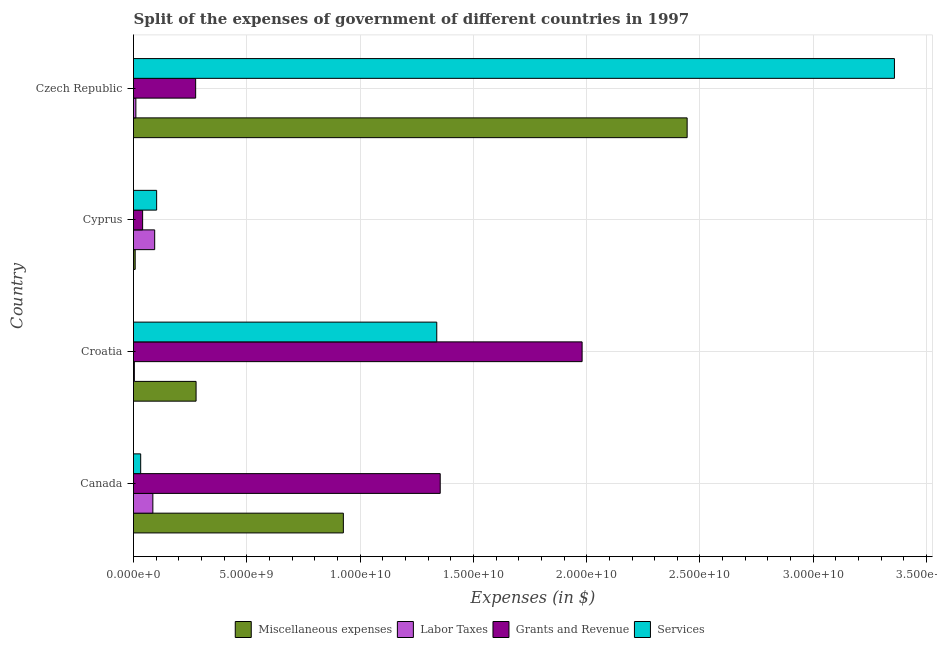How many groups of bars are there?
Make the answer very short. 4. Are the number of bars per tick equal to the number of legend labels?
Provide a succinct answer. Yes. Are the number of bars on each tick of the Y-axis equal?
Keep it short and to the point. Yes. How many bars are there on the 1st tick from the top?
Ensure brevity in your answer.  4. What is the label of the 3rd group of bars from the top?
Provide a short and direct response. Croatia. In how many cases, is the number of bars for a given country not equal to the number of legend labels?
Offer a very short reply. 0. What is the amount spent on services in Canada?
Keep it short and to the point. 3.17e+08. Across all countries, what is the maximum amount spent on grants and revenue?
Your answer should be very brief. 1.98e+1. Across all countries, what is the minimum amount spent on services?
Offer a very short reply. 3.17e+08. In which country was the amount spent on services maximum?
Ensure brevity in your answer.  Czech Republic. In which country was the amount spent on grants and revenue minimum?
Make the answer very short. Cyprus. What is the total amount spent on grants and revenue in the graph?
Keep it short and to the point. 3.65e+1. What is the difference between the amount spent on grants and revenue in Croatia and that in Cyprus?
Give a very brief answer. 1.94e+1. What is the difference between the amount spent on miscellaneous expenses in Croatia and the amount spent on services in Cyprus?
Ensure brevity in your answer.  1.74e+09. What is the average amount spent on labor taxes per country?
Provide a short and direct response. 4.83e+08. What is the difference between the amount spent on grants and revenue and amount spent on miscellaneous expenses in Canada?
Your response must be concise. 4.28e+09. What is the ratio of the amount spent on grants and revenue in Canada to that in Czech Republic?
Give a very brief answer. 4.93. What is the difference between the highest and the second highest amount spent on grants and revenue?
Your answer should be very brief. 6.26e+09. What is the difference between the highest and the lowest amount spent on miscellaneous expenses?
Provide a succinct answer. 2.44e+1. Is the sum of the amount spent on miscellaneous expenses in Canada and Czech Republic greater than the maximum amount spent on services across all countries?
Keep it short and to the point. Yes. Is it the case that in every country, the sum of the amount spent on grants and revenue and amount spent on services is greater than the sum of amount spent on labor taxes and amount spent on miscellaneous expenses?
Provide a succinct answer. No. What does the 4th bar from the top in Cyprus represents?
Make the answer very short. Miscellaneous expenses. What does the 4th bar from the bottom in Canada represents?
Give a very brief answer. Services. Is it the case that in every country, the sum of the amount spent on miscellaneous expenses and amount spent on labor taxes is greater than the amount spent on grants and revenue?
Your answer should be very brief. No. How many bars are there?
Ensure brevity in your answer.  16. How many countries are there in the graph?
Offer a terse response. 4. Are the values on the major ticks of X-axis written in scientific E-notation?
Your response must be concise. Yes. Does the graph contain grids?
Offer a very short reply. Yes. Where does the legend appear in the graph?
Make the answer very short. Bottom center. How are the legend labels stacked?
Your response must be concise. Horizontal. What is the title of the graph?
Give a very brief answer. Split of the expenses of government of different countries in 1997. What is the label or title of the X-axis?
Your answer should be compact. Expenses (in $). What is the Expenses (in $) of Miscellaneous expenses in Canada?
Ensure brevity in your answer.  9.26e+09. What is the Expenses (in $) of Labor Taxes in Canada?
Offer a very short reply. 8.54e+08. What is the Expenses (in $) in Grants and Revenue in Canada?
Ensure brevity in your answer.  1.35e+1. What is the Expenses (in $) in Services in Canada?
Keep it short and to the point. 3.17e+08. What is the Expenses (in $) of Miscellaneous expenses in Croatia?
Keep it short and to the point. 2.76e+09. What is the Expenses (in $) of Labor Taxes in Croatia?
Make the answer very short. 3.79e+07. What is the Expenses (in $) of Grants and Revenue in Croatia?
Offer a terse response. 1.98e+1. What is the Expenses (in $) of Services in Croatia?
Ensure brevity in your answer.  1.34e+1. What is the Expenses (in $) of Miscellaneous expenses in Cyprus?
Keep it short and to the point. 7.36e+07. What is the Expenses (in $) of Labor Taxes in Cyprus?
Keep it short and to the point. 9.35e+08. What is the Expenses (in $) of Grants and Revenue in Cyprus?
Give a very brief answer. 4.02e+08. What is the Expenses (in $) in Services in Cyprus?
Give a very brief answer. 1.02e+09. What is the Expenses (in $) of Miscellaneous expenses in Czech Republic?
Give a very brief answer. 2.44e+1. What is the Expenses (in $) in Labor Taxes in Czech Republic?
Your answer should be very brief. 1.05e+08. What is the Expenses (in $) in Grants and Revenue in Czech Republic?
Provide a short and direct response. 2.74e+09. What is the Expenses (in $) of Services in Czech Republic?
Your response must be concise. 3.36e+1. Across all countries, what is the maximum Expenses (in $) in Miscellaneous expenses?
Make the answer very short. 2.44e+1. Across all countries, what is the maximum Expenses (in $) of Labor Taxes?
Your response must be concise. 9.35e+08. Across all countries, what is the maximum Expenses (in $) of Grants and Revenue?
Your answer should be very brief. 1.98e+1. Across all countries, what is the maximum Expenses (in $) in Services?
Ensure brevity in your answer.  3.36e+1. Across all countries, what is the minimum Expenses (in $) of Miscellaneous expenses?
Your answer should be very brief. 7.36e+07. Across all countries, what is the minimum Expenses (in $) in Labor Taxes?
Your response must be concise. 3.79e+07. Across all countries, what is the minimum Expenses (in $) of Grants and Revenue?
Keep it short and to the point. 4.02e+08. Across all countries, what is the minimum Expenses (in $) of Services?
Provide a succinct answer. 3.17e+08. What is the total Expenses (in $) of Miscellaneous expenses in the graph?
Ensure brevity in your answer.  3.65e+1. What is the total Expenses (in $) of Labor Taxes in the graph?
Provide a succinct answer. 1.93e+09. What is the total Expenses (in $) in Grants and Revenue in the graph?
Provide a succinct answer. 3.65e+1. What is the total Expenses (in $) in Services in the graph?
Give a very brief answer. 4.83e+1. What is the difference between the Expenses (in $) of Miscellaneous expenses in Canada and that in Croatia?
Offer a very short reply. 6.50e+09. What is the difference between the Expenses (in $) in Labor Taxes in Canada and that in Croatia?
Provide a succinct answer. 8.16e+08. What is the difference between the Expenses (in $) in Grants and Revenue in Canada and that in Croatia?
Keep it short and to the point. -6.26e+09. What is the difference between the Expenses (in $) of Services in Canada and that in Croatia?
Keep it short and to the point. -1.31e+1. What is the difference between the Expenses (in $) of Miscellaneous expenses in Canada and that in Cyprus?
Give a very brief answer. 9.19e+09. What is the difference between the Expenses (in $) in Labor Taxes in Canada and that in Cyprus?
Offer a terse response. -8.05e+07. What is the difference between the Expenses (in $) of Grants and Revenue in Canada and that in Cyprus?
Ensure brevity in your answer.  1.31e+1. What is the difference between the Expenses (in $) of Services in Canada and that in Cyprus?
Your response must be concise. -7.04e+08. What is the difference between the Expenses (in $) of Miscellaneous expenses in Canada and that in Czech Republic?
Provide a succinct answer. -1.52e+1. What is the difference between the Expenses (in $) in Labor Taxes in Canada and that in Czech Republic?
Offer a very short reply. 7.49e+08. What is the difference between the Expenses (in $) in Grants and Revenue in Canada and that in Czech Republic?
Offer a very short reply. 1.08e+1. What is the difference between the Expenses (in $) of Services in Canada and that in Czech Republic?
Offer a terse response. -3.33e+1. What is the difference between the Expenses (in $) in Miscellaneous expenses in Croatia and that in Cyprus?
Your answer should be compact. 2.69e+09. What is the difference between the Expenses (in $) in Labor Taxes in Croatia and that in Cyprus?
Keep it short and to the point. -8.97e+08. What is the difference between the Expenses (in $) in Grants and Revenue in Croatia and that in Cyprus?
Make the answer very short. 1.94e+1. What is the difference between the Expenses (in $) of Services in Croatia and that in Cyprus?
Your response must be concise. 1.24e+1. What is the difference between the Expenses (in $) in Miscellaneous expenses in Croatia and that in Czech Republic?
Keep it short and to the point. -2.17e+1. What is the difference between the Expenses (in $) of Labor Taxes in Croatia and that in Czech Republic?
Keep it short and to the point. -6.69e+07. What is the difference between the Expenses (in $) in Grants and Revenue in Croatia and that in Czech Republic?
Ensure brevity in your answer.  1.71e+1. What is the difference between the Expenses (in $) of Services in Croatia and that in Czech Republic?
Provide a succinct answer. -2.02e+1. What is the difference between the Expenses (in $) of Miscellaneous expenses in Cyprus and that in Czech Republic?
Your response must be concise. -2.44e+1. What is the difference between the Expenses (in $) of Labor Taxes in Cyprus and that in Czech Republic?
Offer a very short reply. 8.30e+08. What is the difference between the Expenses (in $) in Grants and Revenue in Cyprus and that in Czech Republic?
Make the answer very short. -2.34e+09. What is the difference between the Expenses (in $) of Services in Cyprus and that in Czech Republic?
Offer a terse response. -3.26e+1. What is the difference between the Expenses (in $) in Miscellaneous expenses in Canada and the Expenses (in $) in Labor Taxes in Croatia?
Your response must be concise. 9.22e+09. What is the difference between the Expenses (in $) of Miscellaneous expenses in Canada and the Expenses (in $) of Grants and Revenue in Croatia?
Keep it short and to the point. -1.05e+1. What is the difference between the Expenses (in $) in Miscellaneous expenses in Canada and the Expenses (in $) in Services in Croatia?
Offer a terse response. -4.12e+09. What is the difference between the Expenses (in $) of Labor Taxes in Canada and the Expenses (in $) of Grants and Revenue in Croatia?
Ensure brevity in your answer.  -1.89e+1. What is the difference between the Expenses (in $) in Labor Taxes in Canada and the Expenses (in $) in Services in Croatia?
Your answer should be very brief. -1.25e+1. What is the difference between the Expenses (in $) of Grants and Revenue in Canada and the Expenses (in $) of Services in Croatia?
Offer a terse response. 1.52e+08. What is the difference between the Expenses (in $) in Miscellaneous expenses in Canada and the Expenses (in $) in Labor Taxes in Cyprus?
Keep it short and to the point. 8.33e+09. What is the difference between the Expenses (in $) of Miscellaneous expenses in Canada and the Expenses (in $) of Grants and Revenue in Cyprus?
Offer a terse response. 8.86e+09. What is the difference between the Expenses (in $) in Miscellaneous expenses in Canada and the Expenses (in $) in Services in Cyprus?
Your response must be concise. 8.24e+09. What is the difference between the Expenses (in $) in Labor Taxes in Canada and the Expenses (in $) in Grants and Revenue in Cyprus?
Your answer should be compact. 4.52e+08. What is the difference between the Expenses (in $) in Labor Taxes in Canada and the Expenses (in $) in Services in Cyprus?
Ensure brevity in your answer.  -1.67e+08. What is the difference between the Expenses (in $) of Grants and Revenue in Canada and the Expenses (in $) of Services in Cyprus?
Your answer should be compact. 1.25e+1. What is the difference between the Expenses (in $) of Miscellaneous expenses in Canada and the Expenses (in $) of Labor Taxes in Czech Republic?
Give a very brief answer. 9.16e+09. What is the difference between the Expenses (in $) in Miscellaneous expenses in Canada and the Expenses (in $) in Grants and Revenue in Czech Republic?
Keep it short and to the point. 6.52e+09. What is the difference between the Expenses (in $) of Miscellaneous expenses in Canada and the Expenses (in $) of Services in Czech Republic?
Keep it short and to the point. -2.43e+1. What is the difference between the Expenses (in $) of Labor Taxes in Canada and the Expenses (in $) of Grants and Revenue in Czech Republic?
Provide a short and direct response. -1.89e+09. What is the difference between the Expenses (in $) of Labor Taxes in Canada and the Expenses (in $) of Services in Czech Republic?
Make the answer very short. -3.27e+1. What is the difference between the Expenses (in $) of Grants and Revenue in Canada and the Expenses (in $) of Services in Czech Republic?
Keep it short and to the point. -2.00e+1. What is the difference between the Expenses (in $) in Miscellaneous expenses in Croatia and the Expenses (in $) in Labor Taxes in Cyprus?
Give a very brief answer. 1.83e+09. What is the difference between the Expenses (in $) in Miscellaneous expenses in Croatia and the Expenses (in $) in Grants and Revenue in Cyprus?
Give a very brief answer. 2.36e+09. What is the difference between the Expenses (in $) in Miscellaneous expenses in Croatia and the Expenses (in $) in Services in Cyprus?
Your response must be concise. 1.74e+09. What is the difference between the Expenses (in $) of Labor Taxes in Croatia and the Expenses (in $) of Grants and Revenue in Cyprus?
Make the answer very short. -3.64e+08. What is the difference between the Expenses (in $) in Labor Taxes in Croatia and the Expenses (in $) in Services in Cyprus?
Offer a terse response. -9.83e+08. What is the difference between the Expenses (in $) of Grants and Revenue in Croatia and the Expenses (in $) of Services in Cyprus?
Give a very brief answer. 1.88e+1. What is the difference between the Expenses (in $) of Miscellaneous expenses in Croatia and the Expenses (in $) of Labor Taxes in Czech Republic?
Keep it short and to the point. 2.66e+09. What is the difference between the Expenses (in $) of Miscellaneous expenses in Croatia and the Expenses (in $) of Grants and Revenue in Czech Republic?
Provide a short and direct response. 1.83e+07. What is the difference between the Expenses (in $) in Miscellaneous expenses in Croatia and the Expenses (in $) in Services in Czech Republic?
Your answer should be compact. -3.08e+1. What is the difference between the Expenses (in $) in Labor Taxes in Croatia and the Expenses (in $) in Grants and Revenue in Czech Republic?
Offer a terse response. -2.70e+09. What is the difference between the Expenses (in $) in Labor Taxes in Croatia and the Expenses (in $) in Services in Czech Republic?
Your answer should be very brief. -3.35e+1. What is the difference between the Expenses (in $) in Grants and Revenue in Croatia and the Expenses (in $) in Services in Czech Republic?
Provide a short and direct response. -1.38e+1. What is the difference between the Expenses (in $) in Miscellaneous expenses in Cyprus and the Expenses (in $) in Labor Taxes in Czech Republic?
Ensure brevity in your answer.  -3.12e+07. What is the difference between the Expenses (in $) of Miscellaneous expenses in Cyprus and the Expenses (in $) of Grants and Revenue in Czech Republic?
Offer a very short reply. -2.67e+09. What is the difference between the Expenses (in $) in Miscellaneous expenses in Cyprus and the Expenses (in $) in Services in Czech Republic?
Make the answer very short. -3.35e+1. What is the difference between the Expenses (in $) of Labor Taxes in Cyprus and the Expenses (in $) of Grants and Revenue in Czech Republic?
Provide a succinct answer. -1.81e+09. What is the difference between the Expenses (in $) of Labor Taxes in Cyprus and the Expenses (in $) of Services in Czech Republic?
Keep it short and to the point. -3.26e+1. What is the difference between the Expenses (in $) of Grants and Revenue in Cyprus and the Expenses (in $) of Services in Czech Republic?
Ensure brevity in your answer.  -3.32e+1. What is the average Expenses (in $) of Miscellaneous expenses per country?
Your response must be concise. 9.13e+09. What is the average Expenses (in $) of Labor Taxes per country?
Make the answer very short. 4.83e+08. What is the average Expenses (in $) in Grants and Revenue per country?
Offer a very short reply. 9.12e+09. What is the average Expenses (in $) of Services per country?
Your answer should be very brief. 1.21e+1. What is the difference between the Expenses (in $) in Miscellaneous expenses and Expenses (in $) in Labor Taxes in Canada?
Provide a short and direct response. 8.41e+09. What is the difference between the Expenses (in $) in Miscellaneous expenses and Expenses (in $) in Grants and Revenue in Canada?
Offer a terse response. -4.28e+09. What is the difference between the Expenses (in $) in Miscellaneous expenses and Expenses (in $) in Services in Canada?
Your answer should be compact. 8.94e+09. What is the difference between the Expenses (in $) in Labor Taxes and Expenses (in $) in Grants and Revenue in Canada?
Provide a succinct answer. -1.27e+1. What is the difference between the Expenses (in $) of Labor Taxes and Expenses (in $) of Services in Canada?
Your response must be concise. 5.37e+08. What is the difference between the Expenses (in $) of Grants and Revenue and Expenses (in $) of Services in Canada?
Offer a very short reply. 1.32e+1. What is the difference between the Expenses (in $) of Miscellaneous expenses and Expenses (in $) of Labor Taxes in Croatia?
Make the answer very short. 2.72e+09. What is the difference between the Expenses (in $) of Miscellaneous expenses and Expenses (in $) of Grants and Revenue in Croatia?
Your answer should be very brief. -1.70e+1. What is the difference between the Expenses (in $) in Miscellaneous expenses and Expenses (in $) in Services in Croatia?
Give a very brief answer. -1.06e+1. What is the difference between the Expenses (in $) in Labor Taxes and Expenses (in $) in Grants and Revenue in Croatia?
Your answer should be very brief. -1.98e+1. What is the difference between the Expenses (in $) of Labor Taxes and Expenses (in $) of Services in Croatia?
Offer a very short reply. -1.33e+1. What is the difference between the Expenses (in $) of Grants and Revenue and Expenses (in $) of Services in Croatia?
Your answer should be very brief. 6.41e+09. What is the difference between the Expenses (in $) of Miscellaneous expenses and Expenses (in $) of Labor Taxes in Cyprus?
Give a very brief answer. -8.61e+08. What is the difference between the Expenses (in $) of Miscellaneous expenses and Expenses (in $) of Grants and Revenue in Cyprus?
Offer a very short reply. -3.29e+08. What is the difference between the Expenses (in $) of Miscellaneous expenses and Expenses (in $) of Services in Cyprus?
Provide a succinct answer. -9.47e+08. What is the difference between the Expenses (in $) of Labor Taxes and Expenses (in $) of Grants and Revenue in Cyprus?
Your answer should be compact. 5.32e+08. What is the difference between the Expenses (in $) in Labor Taxes and Expenses (in $) in Services in Cyprus?
Your answer should be very brief. -8.64e+07. What is the difference between the Expenses (in $) in Grants and Revenue and Expenses (in $) in Services in Cyprus?
Offer a terse response. -6.19e+08. What is the difference between the Expenses (in $) in Miscellaneous expenses and Expenses (in $) in Labor Taxes in Czech Republic?
Offer a very short reply. 2.43e+1. What is the difference between the Expenses (in $) in Miscellaneous expenses and Expenses (in $) in Grants and Revenue in Czech Republic?
Your response must be concise. 2.17e+1. What is the difference between the Expenses (in $) in Miscellaneous expenses and Expenses (in $) in Services in Czech Republic?
Provide a short and direct response. -9.15e+09. What is the difference between the Expenses (in $) in Labor Taxes and Expenses (in $) in Grants and Revenue in Czech Republic?
Give a very brief answer. -2.64e+09. What is the difference between the Expenses (in $) in Labor Taxes and Expenses (in $) in Services in Czech Republic?
Offer a very short reply. -3.35e+1. What is the difference between the Expenses (in $) in Grants and Revenue and Expenses (in $) in Services in Czech Republic?
Keep it short and to the point. -3.08e+1. What is the ratio of the Expenses (in $) of Miscellaneous expenses in Canada to that in Croatia?
Your answer should be compact. 3.35. What is the ratio of the Expenses (in $) of Labor Taxes in Canada to that in Croatia?
Your response must be concise. 22.52. What is the ratio of the Expenses (in $) of Grants and Revenue in Canada to that in Croatia?
Offer a terse response. 0.68. What is the ratio of the Expenses (in $) in Services in Canada to that in Croatia?
Keep it short and to the point. 0.02. What is the ratio of the Expenses (in $) of Miscellaneous expenses in Canada to that in Cyprus?
Make the answer very short. 125.89. What is the ratio of the Expenses (in $) of Labor Taxes in Canada to that in Cyprus?
Ensure brevity in your answer.  0.91. What is the ratio of the Expenses (in $) of Grants and Revenue in Canada to that in Cyprus?
Make the answer very short. 33.64. What is the ratio of the Expenses (in $) in Services in Canada to that in Cyprus?
Your response must be concise. 0.31. What is the ratio of the Expenses (in $) in Miscellaneous expenses in Canada to that in Czech Republic?
Your answer should be very brief. 0.38. What is the ratio of the Expenses (in $) in Labor Taxes in Canada to that in Czech Republic?
Keep it short and to the point. 8.15. What is the ratio of the Expenses (in $) of Grants and Revenue in Canada to that in Czech Republic?
Offer a terse response. 4.93. What is the ratio of the Expenses (in $) in Services in Canada to that in Czech Republic?
Make the answer very short. 0.01. What is the ratio of the Expenses (in $) of Miscellaneous expenses in Croatia to that in Cyprus?
Provide a succinct answer. 37.53. What is the ratio of the Expenses (in $) of Labor Taxes in Croatia to that in Cyprus?
Your answer should be compact. 0.04. What is the ratio of the Expenses (in $) in Grants and Revenue in Croatia to that in Cyprus?
Your response must be concise. 49.21. What is the ratio of the Expenses (in $) of Services in Croatia to that in Cyprus?
Offer a terse response. 13.11. What is the ratio of the Expenses (in $) of Miscellaneous expenses in Croatia to that in Czech Republic?
Make the answer very short. 0.11. What is the ratio of the Expenses (in $) in Labor Taxes in Croatia to that in Czech Republic?
Offer a terse response. 0.36. What is the ratio of the Expenses (in $) in Grants and Revenue in Croatia to that in Czech Republic?
Keep it short and to the point. 7.22. What is the ratio of the Expenses (in $) of Services in Croatia to that in Czech Republic?
Offer a terse response. 0.4. What is the ratio of the Expenses (in $) in Miscellaneous expenses in Cyprus to that in Czech Republic?
Offer a terse response. 0. What is the ratio of the Expenses (in $) in Labor Taxes in Cyprus to that in Czech Republic?
Offer a terse response. 8.92. What is the ratio of the Expenses (in $) in Grants and Revenue in Cyprus to that in Czech Republic?
Keep it short and to the point. 0.15. What is the ratio of the Expenses (in $) in Services in Cyprus to that in Czech Republic?
Keep it short and to the point. 0.03. What is the difference between the highest and the second highest Expenses (in $) of Miscellaneous expenses?
Ensure brevity in your answer.  1.52e+1. What is the difference between the highest and the second highest Expenses (in $) in Labor Taxes?
Offer a terse response. 8.05e+07. What is the difference between the highest and the second highest Expenses (in $) of Grants and Revenue?
Offer a terse response. 6.26e+09. What is the difference between the highest and the second highest Expenses (in $) of Services?
Make the answer very short. 2.02e+1. What is the difference between the highest and the lowest Expenses (in $) in Miscellaneous expenses?
Provide a succinct answer. 2.44e+1. What is the difference between the highest and the lowest Expenses (in $) of Labor Taxes?
Offer a very short reply. 8.97e+08. What is the difference between the highest and the lowest Expenses (in $) in Grants and Revenue?
Your response must be concise. 1.94e+1. What is the difference between the highest and the lowest Expenses (in $) in Services?
Your answer should be very brief. 3.33e+1. 